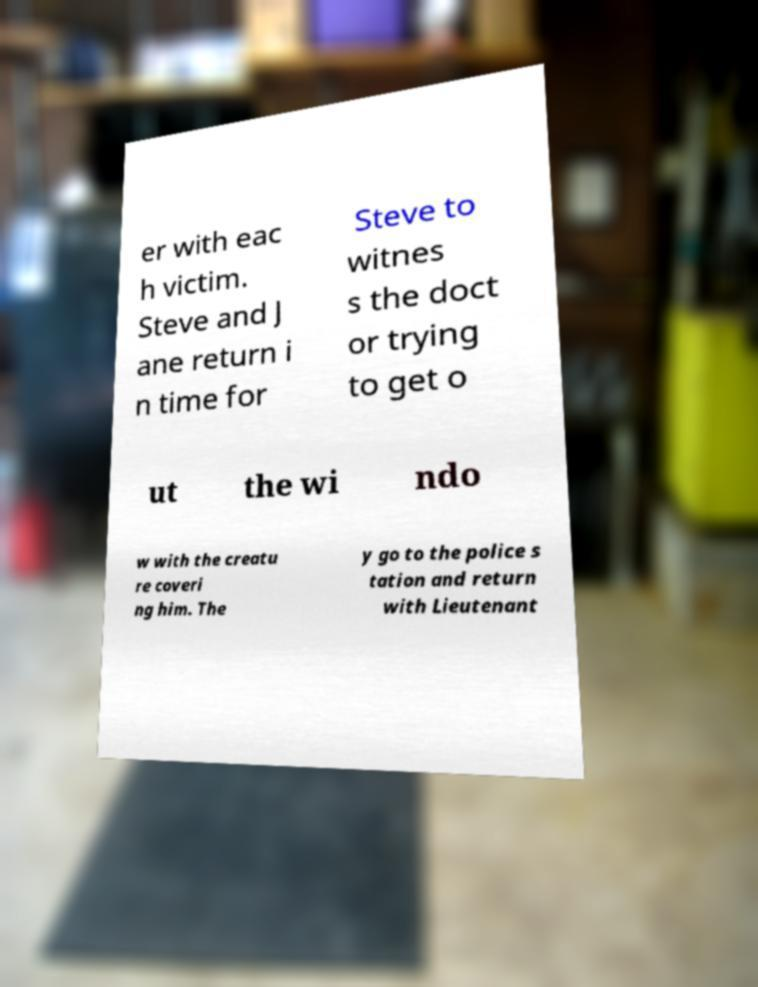Can you read and provide the text displayed in the image?This photo seems to have some interesting text. Can you extract and type it out for me? er with eac h victim. Steve and J ane return i n time for Steve to witnes s the doct or trying to get o ut the wi ndo w with the creatu re coveri ng him. The y go to the police s tation and return with Lieutenant 